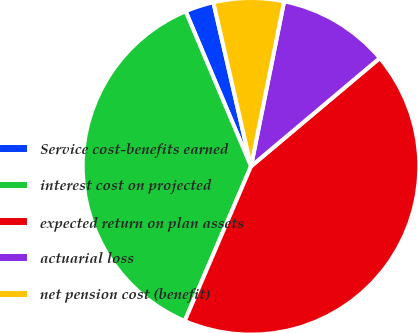Convert chart. <chart><loc_0><loc_0><loc_500><loc_500><pie_chart><fcel>Service cost-benefits earned<fcel>interest cost on projected<fcel>expected return on plan assets<fcel>actuarial loss<fcel>net pension cost (benefit)<nl><fcel>2.76%<fcel>37.2%<fcel>42.57%<fcel>10.72%<fcel>6.74%<nl></chart> 